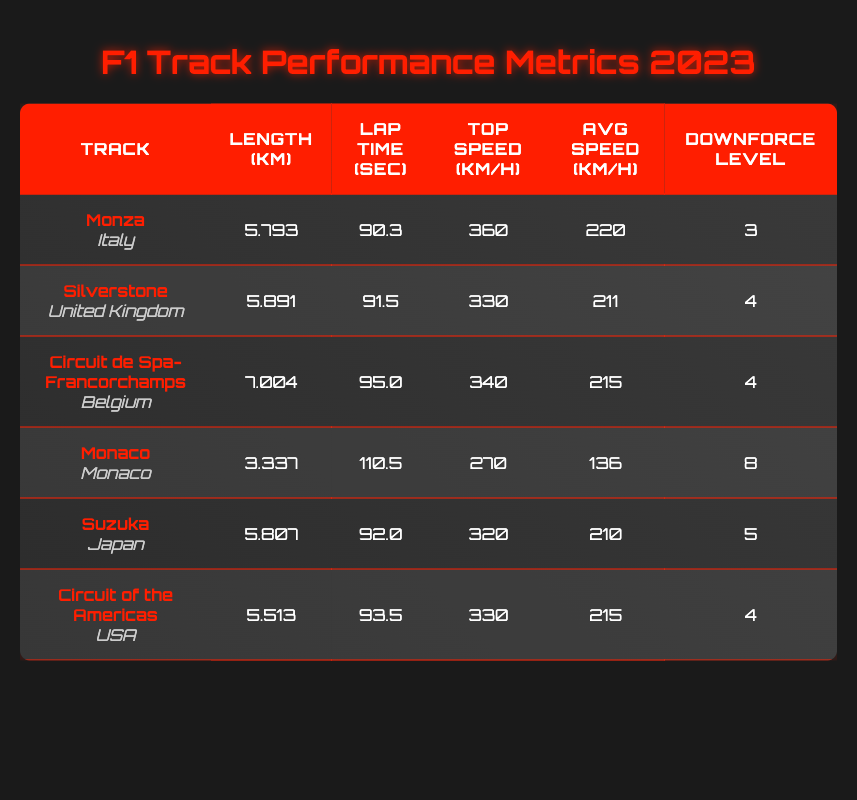What is the top speed of the car at Monza? The table states that the top speed at Monza is 360 km/h, which can be found in the corresponding row under the "Top Speed (km/h)" column.
Answer: 360 km/h Which track has the highest downforce level? By examining the "Downforce Level" column, Monaco has the highest value listed as 8, higher than any other track.
Answer: Monaco What is the average lap time of the tracks listed? To find the average lap time, we sum the lap times: 90.3 + 91.5 + 95.0 + 110.5 + 92.0 + 93.5 = 572.8 seconds. There are 6 tracks, so the average is 572.8 / 6 ≈ 95.47 seconds.
Answer: Approximately 95.47 seconds Is the average speed at Suzuka greater than that at Silverstone? Checking the "Average Speed (km/h)" column, Suzuka's average speed is 210 km/h, while Silverstone's is 211 km/h. Therefore, Suzuka's average speed is not greater.
Answer: No What is the difference in lap times between Monaco and Circuit de Spa-Francorchamps? The lap time for Monaco is 110.5 seconds and for Circuit de Spa-Francorchamps, it is 95.0 seconds. The difference is 110.5 - 95.0 = 15.5 seconds.
Answer: 15.5 seconds Which track has the shortest length? Looking at the "Length (km)" column, Monaco is the shortest with 3.337 km, which is less than the others.
Answer: Monaco Do any tracks have a top speed of 330 km/h? Yes, by reviewing the "Top Speed (km/h)" column, both Silverstone and Circuit of the Americas have a top speed of 330 km/h.
Answer: Yes If you add together the lengths of all tracks, what is the total? Summing the lengths: 5.793 + 5.891 + 7.004 + 3.337 + 5.807 + 5.513 = 33.345 km. Therefore, the total length is 33.345 km.
Answer: 33.345 km 